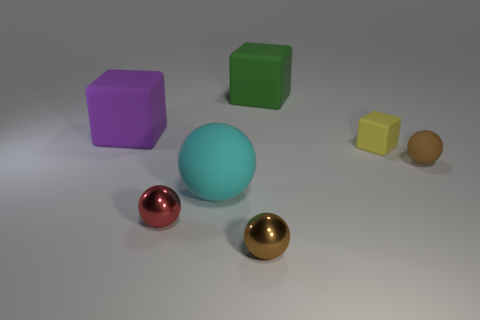Do the brown thing that is in front of the brown rubber ball and the large purple rubber object have the same size?
Offer a terse response. No. Is the material of the yellow thing the same as the big purple object?
Offer a terse response. Yes. What number of large objects are either gray cylinders or red shiny spheres?
Provide a succinct answer. 0. What is the color of the object that is the same material as the red sphere?
Your answer should be compact. Brown. The small block that is behind the cyan matte object is what color?
Your answer should be compact. Yellow. What number of other spheres have the same color as the small matte sphere?
Your response must be concise. 1. Are there fewer large green rubber cubes that are left of the tiny red ball than purple matte things to the right of the small brown metal object?
Keep it short and to the point. No. There is a cyan sphere; what number of large cyan spheres are left of it?
Your response must be concise. 0. Is there a small green sphere that has the same material as the small yellow cube?
Ensure brevity in your answer.  No. Are there more brown balls behind the small brown metallic object than brown matte spheres that are to the left of the red metallic thing?
Your response must be concise. Yes. 